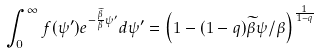Convert formula to latex. <formula><loc_0><loc_0><loc_500><loc_500>\int _ { 0 } ^ { \infty } f ( \psi ^ { \prime } ) e ^ { - \frac { \widetilde { \beta } } { \beta } \psi ^ { \prime } } d \psi ^ { \prime } = \left ( 1 - ( 1 - q ) \widetilde { \beta } \psi / \beta \right ) ^ { \frac { 1 } { 1 - q } }</formula> 